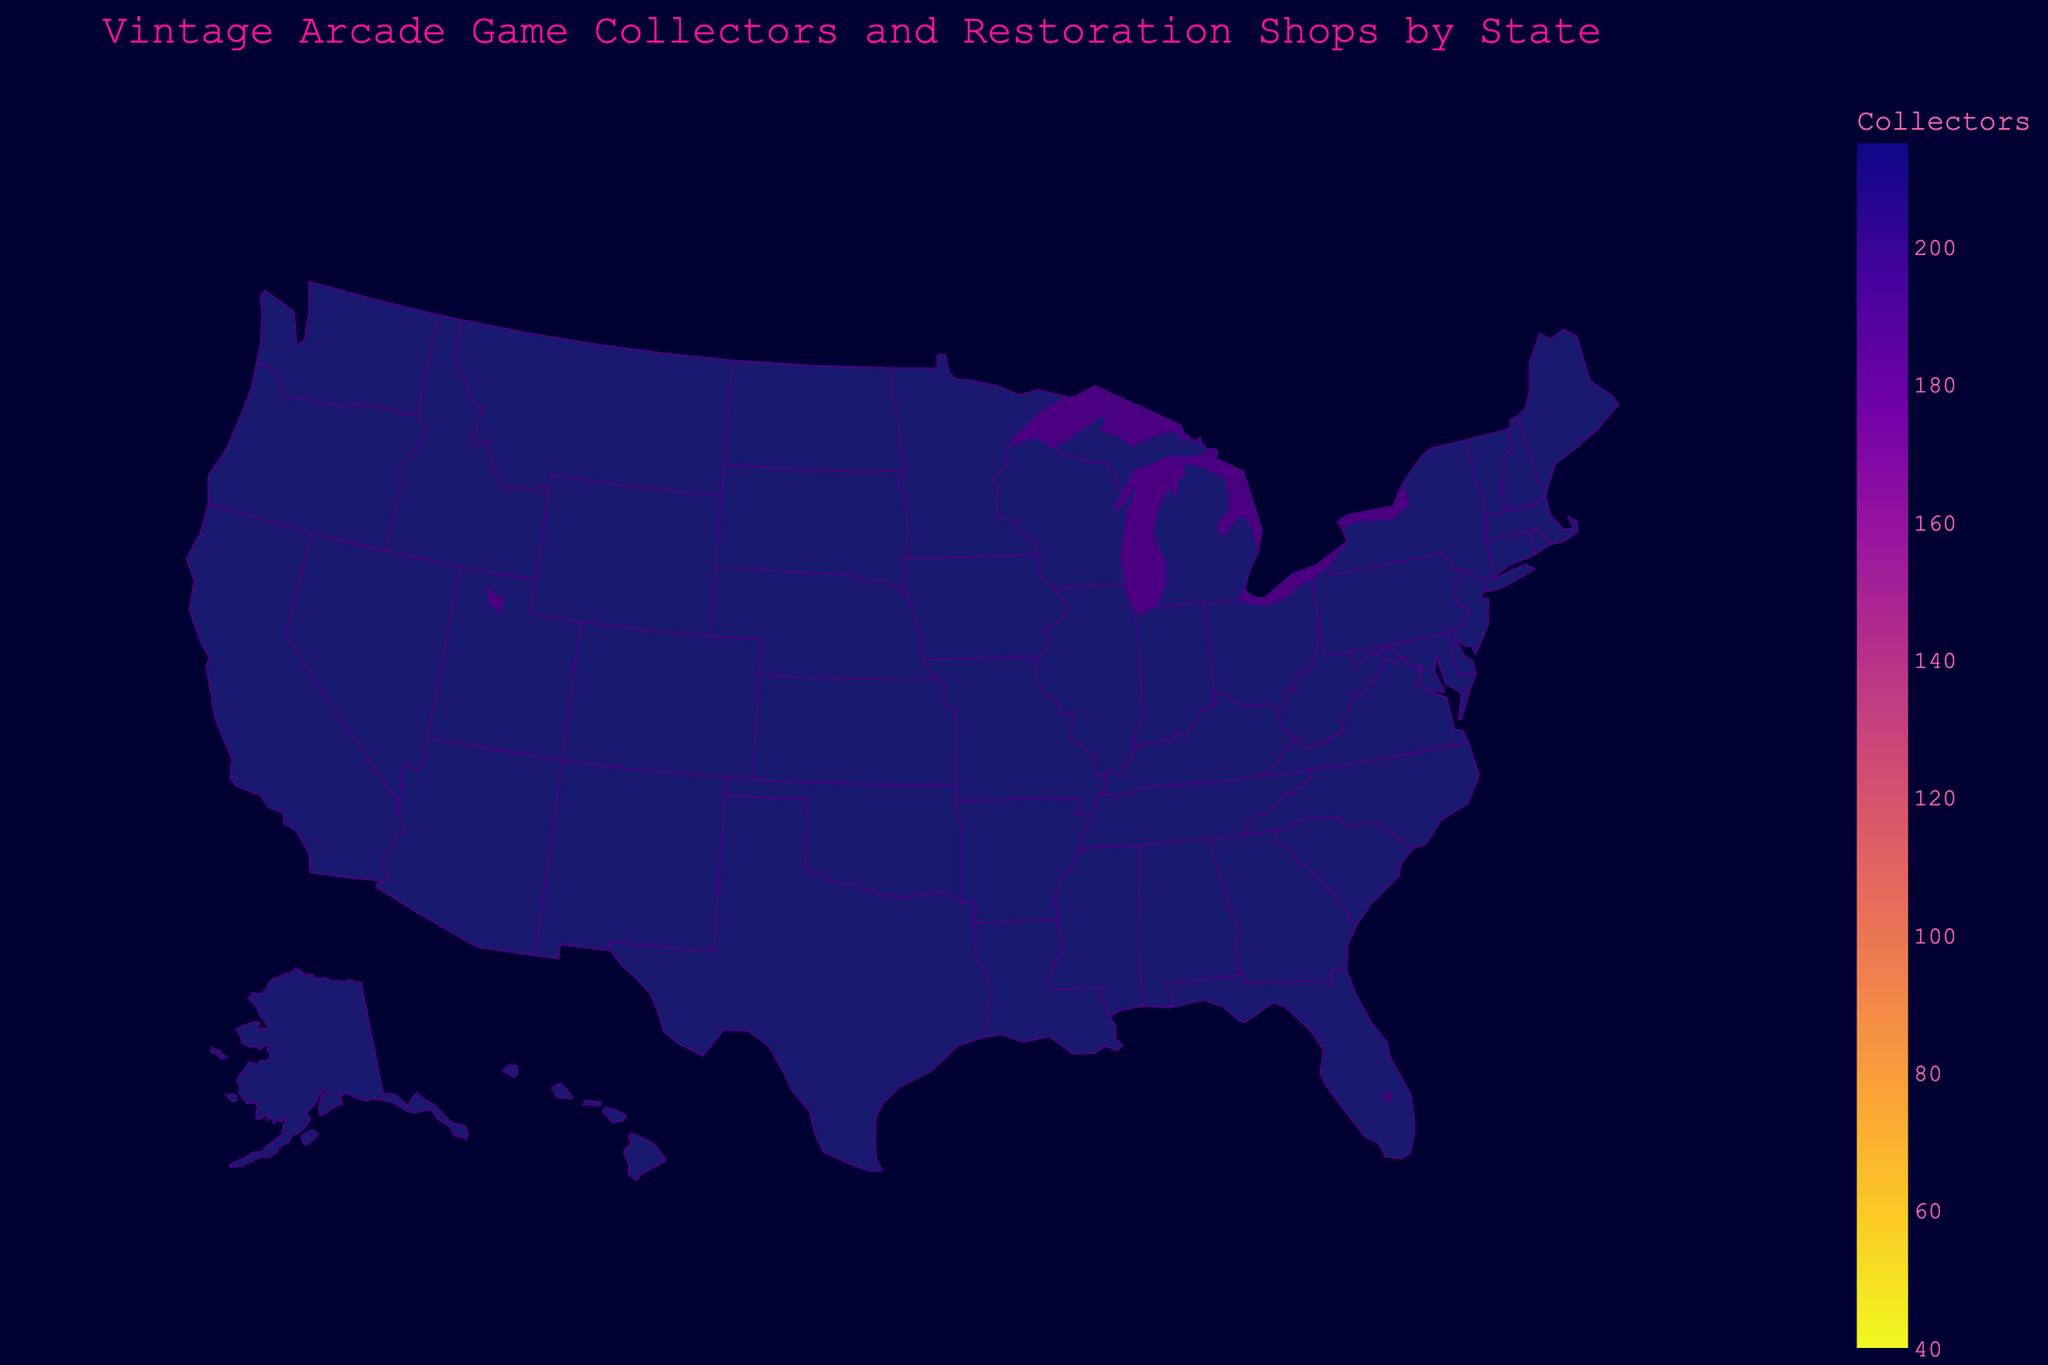What is the most popular arcade game in California? According to the hover text, California's popular game is Pac-Man.
Answer: Pac-Man Which state has the highest number of vintage arcade game collectors? The color intensity on the choropleth map indicates California has the highest value. According to the hover data, California has 215 collectors.
Answer: California How many restoration shops are there in New York? Hovering over New York shows that it has 15 restoration shops.
Answer: 15 What are the total number of vintage arcade game collectors in Texas and Florida combined? Look at the values for collectors in Texas (150) and Florida (130), then sum them: 150 + 130 = 280.
Answer: 280 Which state has fewer collectors, Michigan or Georgia? According to the hover text, Michigan has 65 collectors and Georgia has 55. So, Georgia has fewer collectors.
Answer: Georgia How does the number of restoration shops in Illinois and Oregon compare? Illinois has 8 restoration shops and Oregon has 5 as shown in the hover data. Illinois has 3 more shops than Oregon.
Answer: Illinois has more What is the primary color used for the text annotations? By examining the colors used in the plot, the annotations for restoration shops are in a neon cyan color.
Answer: Neon cyan Which game is more popular in Massachusetts, Asteroids or Space Invaders? According to the hover text in Massachusetts, the popular game is Asteroids.
Answer: Asteroids What is the average number of collectors in the states with fewer than 10 restoration shops? States with fewer than 10 shops: Florida (130), Illinois (120), Massachusetts (85), Oregon (75), Colorado (70), Michigan (65), New Jersey (60), Georgia (55), Pennsylvania (50), Arizona (45), Ohio (40). Sum the collectors (130+120+85+75+70+65+60+55+50+45+40=795) and divide by the number of states (11): 795 / 11 ≈ 72.27.
Answer: 72.27 Which region has the least number of collectors and what is the popular game there? By examining the hover text, Ohio has the least number of collectors at 40, and the popular game is Dig Dug.
Answer: Ohio, Dig Dug 